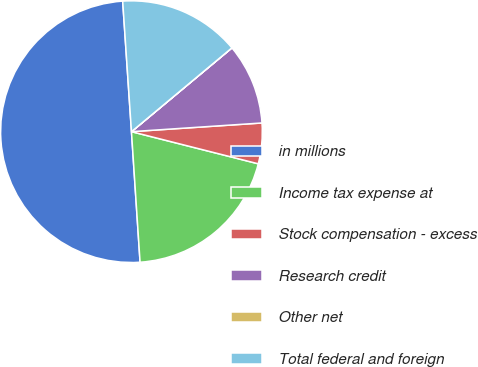<chart> <loc_0><loc_0><loc_500><loc_500><pie_chart><fcel>in millions<fcel>Income tax expense at<fcel>Stock compensation - excess<fcel>Research credit<fcel>Other net<fcel>Total federal and foreign<nl><fcel>49.98%<fcel>20.0%<fcel>5.01%<fcel>10.0%<fcel>0.01%<fcel>15.0%<nl></chart> 